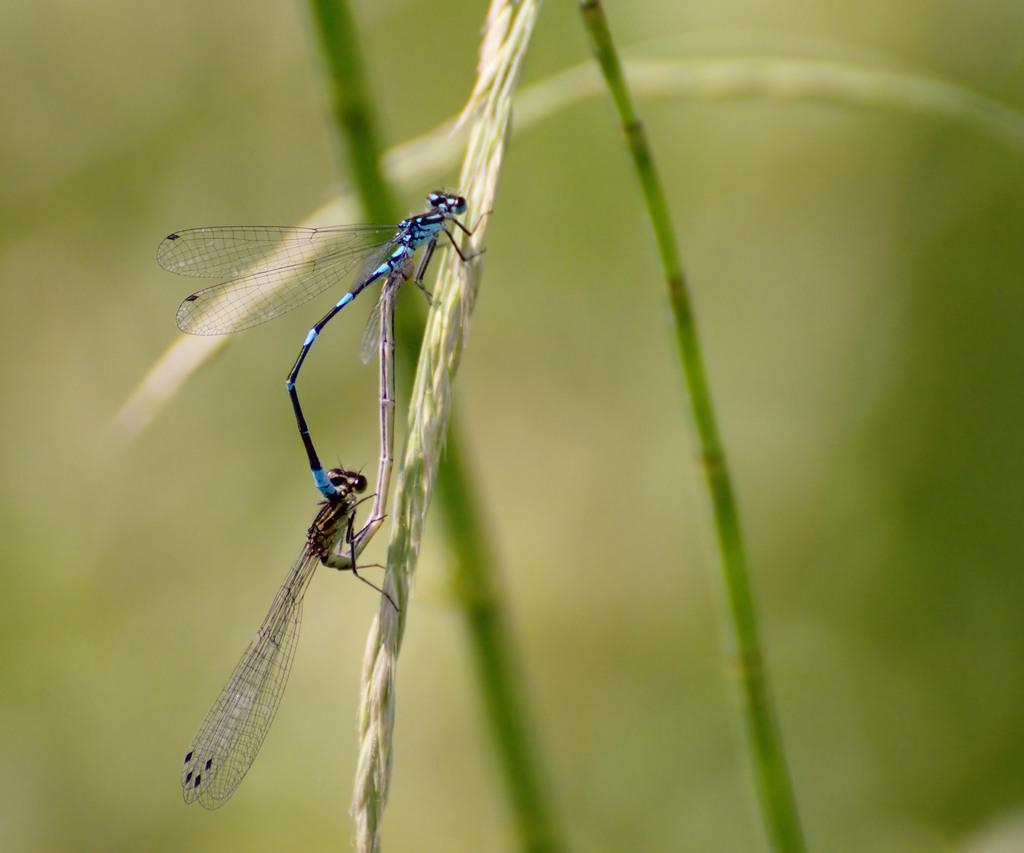What type of insects are in the picture? There are Dragonflies in the picture. Where are the Dragonflies located? The Dragonflies are on a plant. What colors are the Dragonflies? The Dragonflies are blue and black in color. What type of net is being used to catch the steam in the picture? There is no net or steam present in the image; it features Dragonflies on a plant. 